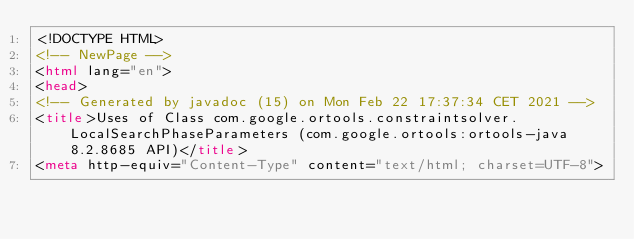Convert code to text. <code><loc_0><loc_0><loc_500><loc_500><_HTML_><!DOCTYPE HTML>
<!-- NewPage -->
<html lang="en">
<head>
<!-- Generated by javadoc (15) on Mon Feb 22 17:37:34 CET 2021 -->
<title>Uses of Class com.google.ortools.constraintsolver.LocalSearchPhaseParameters (com.google.ortools:ortools-java 8.2.8685 API)</title>
<meta http-equiv="Content-Type" content="text/html; charset=UTF-8"></code> 